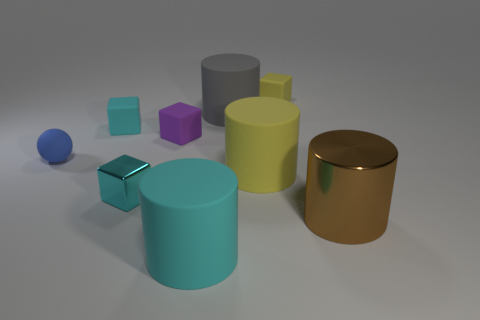Subtract 1 blocks. How many blocks are left? 3 Add 1 cyan balls. How many objects exist? 10 Subtract all cylinders. How many objects are left? 5 Subtract all blue blocks. Subtract all blocks. How many objects are left? 5 Add 1 large cyan objects. How many large cyan objects are left? 2 Add 8 big brown objects. How many big brown objects exist? 9 Subtract 0 gray cubes. How many objects are left? 9 